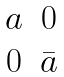Convert formula to latex. <formula><loc_0><loc_0><loc_500><loc_500>\begin{matrix} a & 0 \\ 0 & \bar { a } \\ \end{matrix}</formula> 